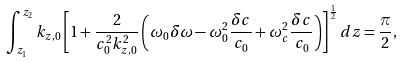<formula> <loc_0><loc_0><loc_500><loc_500>\int _ { z _ { 1 } } ^ { z _ { 2 } } k _ { z , 0 } \left [ 1 + \frac { 2 } { c _ { 0 } ^ { 2 } k _ { z , 0 } ^ { 2 } } \left ( \omega _ { 0 } \delta \omega - \omega _ { 0 } ^ { 2 } \frac { \delta c } { c _ { 0 } } + \omega _ { c } ^ { 2 } \frac { \delta c } { c _ { 0 } } \right ) \right ] ^ { \frac { 1 } { 2 } } d z = \frac { \pi } { 2 } ,</formula> 